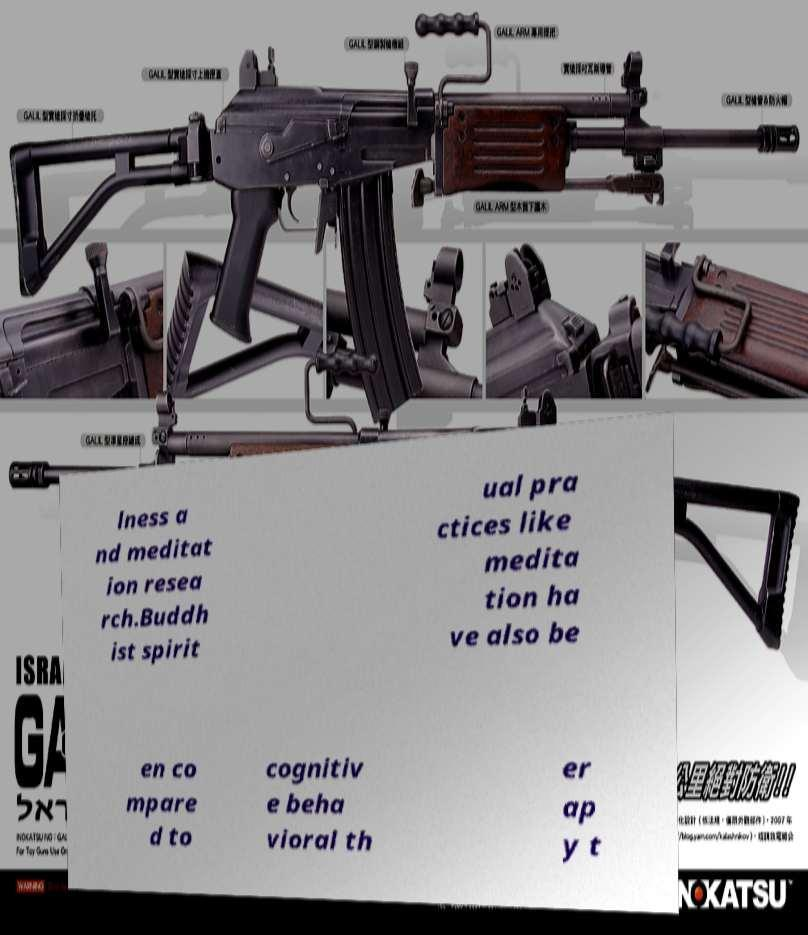Can you accurately transcribe the text from the provided image for me? lness a nd meditat ion resea rch.Buddh ist spirit ual pra ctices like medita tion ha ve also be en co mpare d to cognitiv e beha vioral th er ap y t 